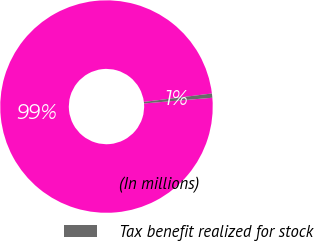Convert chart. <chart><loc_0><loc_0><loc_500><loc_500><pie_chart><fcel>(In millions)<fcel>Tax benefit realized for stock<nl><fcel>99.36%<fcel>0.64%<nl></chart> 